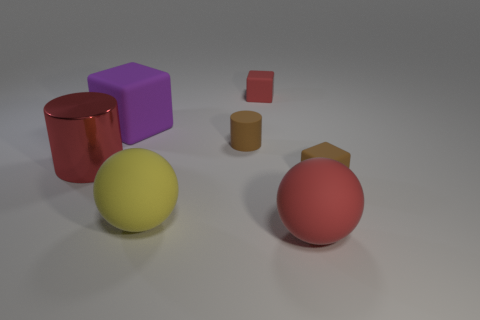Is the color of the large object left of the purple matte thing the same as the big matte thing that is behind the tiny brown cylinder?
Ensure brevity in your answer.  No. There is a large red matte ball; what number of red rubber objects are behind it?
Provide a succinct answer. 1. What number of big shiny objects are the same color as the big cylinder?
Offer a terse response. 0. Is the brown object right of the small matte cylinder made of the same material as the big yellow sphere?
Offer a very short reply. Yes. How many large yellow objects are made of the same material as the big cylinder?
Provide a short and direct response. 0. Are there more rubber blocks in front of the red cube than small green shiny spheres?
Provide a short and direct response. Yes. There is a sphere that is the same color as the metal cylinder; what is its size?
Provide a short and direct response. Large. Are there any other tiny red things that have the same shape as the tiny red matte object?
Offer a terse response. No. What number of objects are red cylinders or tiny red cubes?
Your answer should be very brief. 2. There is a large red thing that is right of the small cube behind the big metallic cylinder; how many red things are behind it?
Ensure brevity in your answer.  2. 